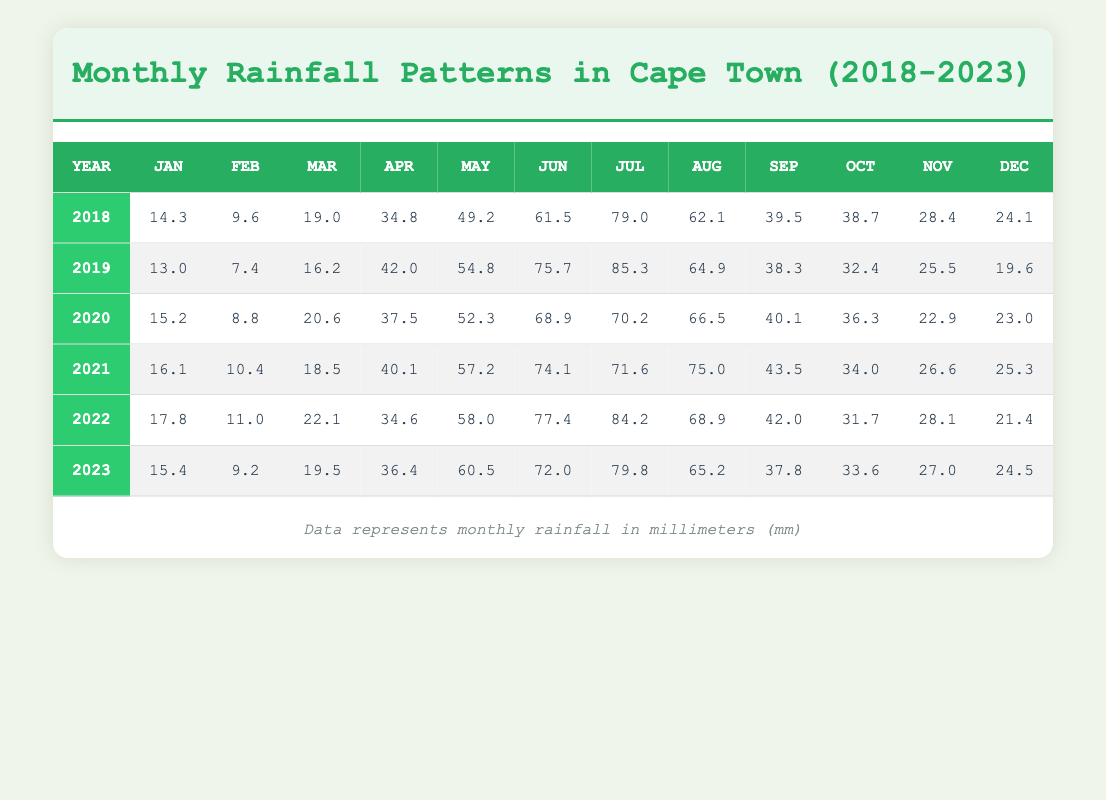What is the total rainfall in Cape Town for the year 2021? To find the total rainfall for 2021, we add the monthly figures: 16.1 + 10.4 + 18.5 + 40.1 + 57.2 + 74.1 + 71.6 + 75.0 + 43.5 + 34.0 + 26.6 + 25.3 =  471.0 mm
Answer: 471.0 mm Which month had the highest average rainfall over the five years? By reviewing each month across the five years: January averages 15.0 mm, February averages 9.4 mm, March averages 19.0 mm, April averages 42.6 mm, May averages 54.4 mm, June averages 66.7 mm, July averages 78.1 mm, August averages 63.7 mm, September averages 40.4 mm, October averages 34.4 mm, November averages 27.9 mm, December averages 23.5 mm. July has the highest average with 78.1 mm
Answer: July Did Cape Town receive more rainfall in 2022 compared to 2021? To compare the total rainfall in both years: For 2022, total is 473.2 mm, and for 2021, it's 471.0 mm. Since 473.2 is greater than 471.0, the statement is true
Answer: Yes How much more rainfall was recorded in June 2019 compared to June 2022? The rainfall for June 2019 was 75.7 mm while June 2022 was 77.4 mm. To find the difference, subtract: 77.4 - 75.7 = 1.7 mm. Hence, June 2022 had 1.7 mm more rainfall
Answer: 1.7 mm What was the median rainfall for the month of September over the years? The September values are: 39.5, 38.3, 40.1, 43.5, 42.0, 37.8. Arranging these values: 37.8, 38.3, 39.5, 40.1, 42.0, 43.5. There are six numbers, so the median will be the average of the 3rd and 4th values: (39.5 + 40.1) / 2 = 39.8 mm
Answer: 39.8 mm 